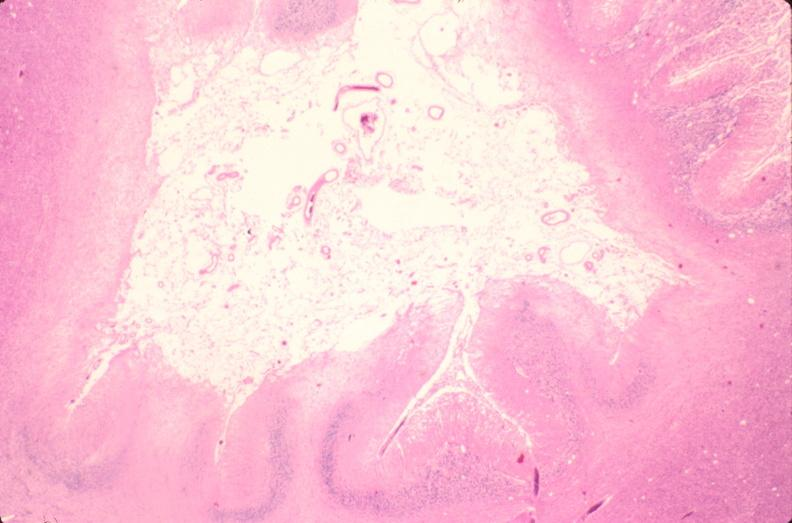what is present?
Answer the question using a single word or phrase. Nervous 